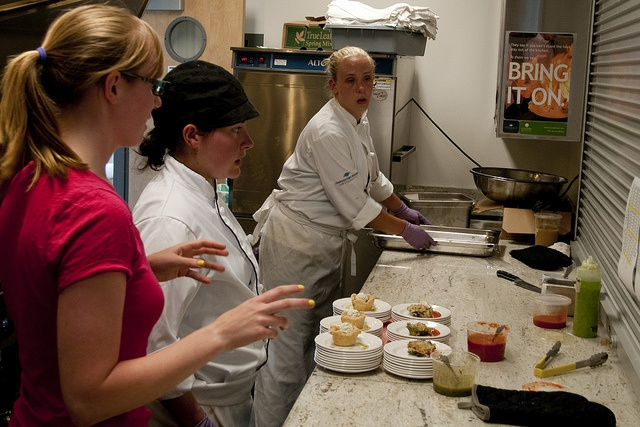Describe the objects in this image and their specific colors. I can see people in black, maroon, and brown tones, people in black, gray, darkgray, and maroon tones, people in black, gray, and maroon tones, bowl in black and gray tones, and bottle in black, darkgreen, and olive tones in this image. 